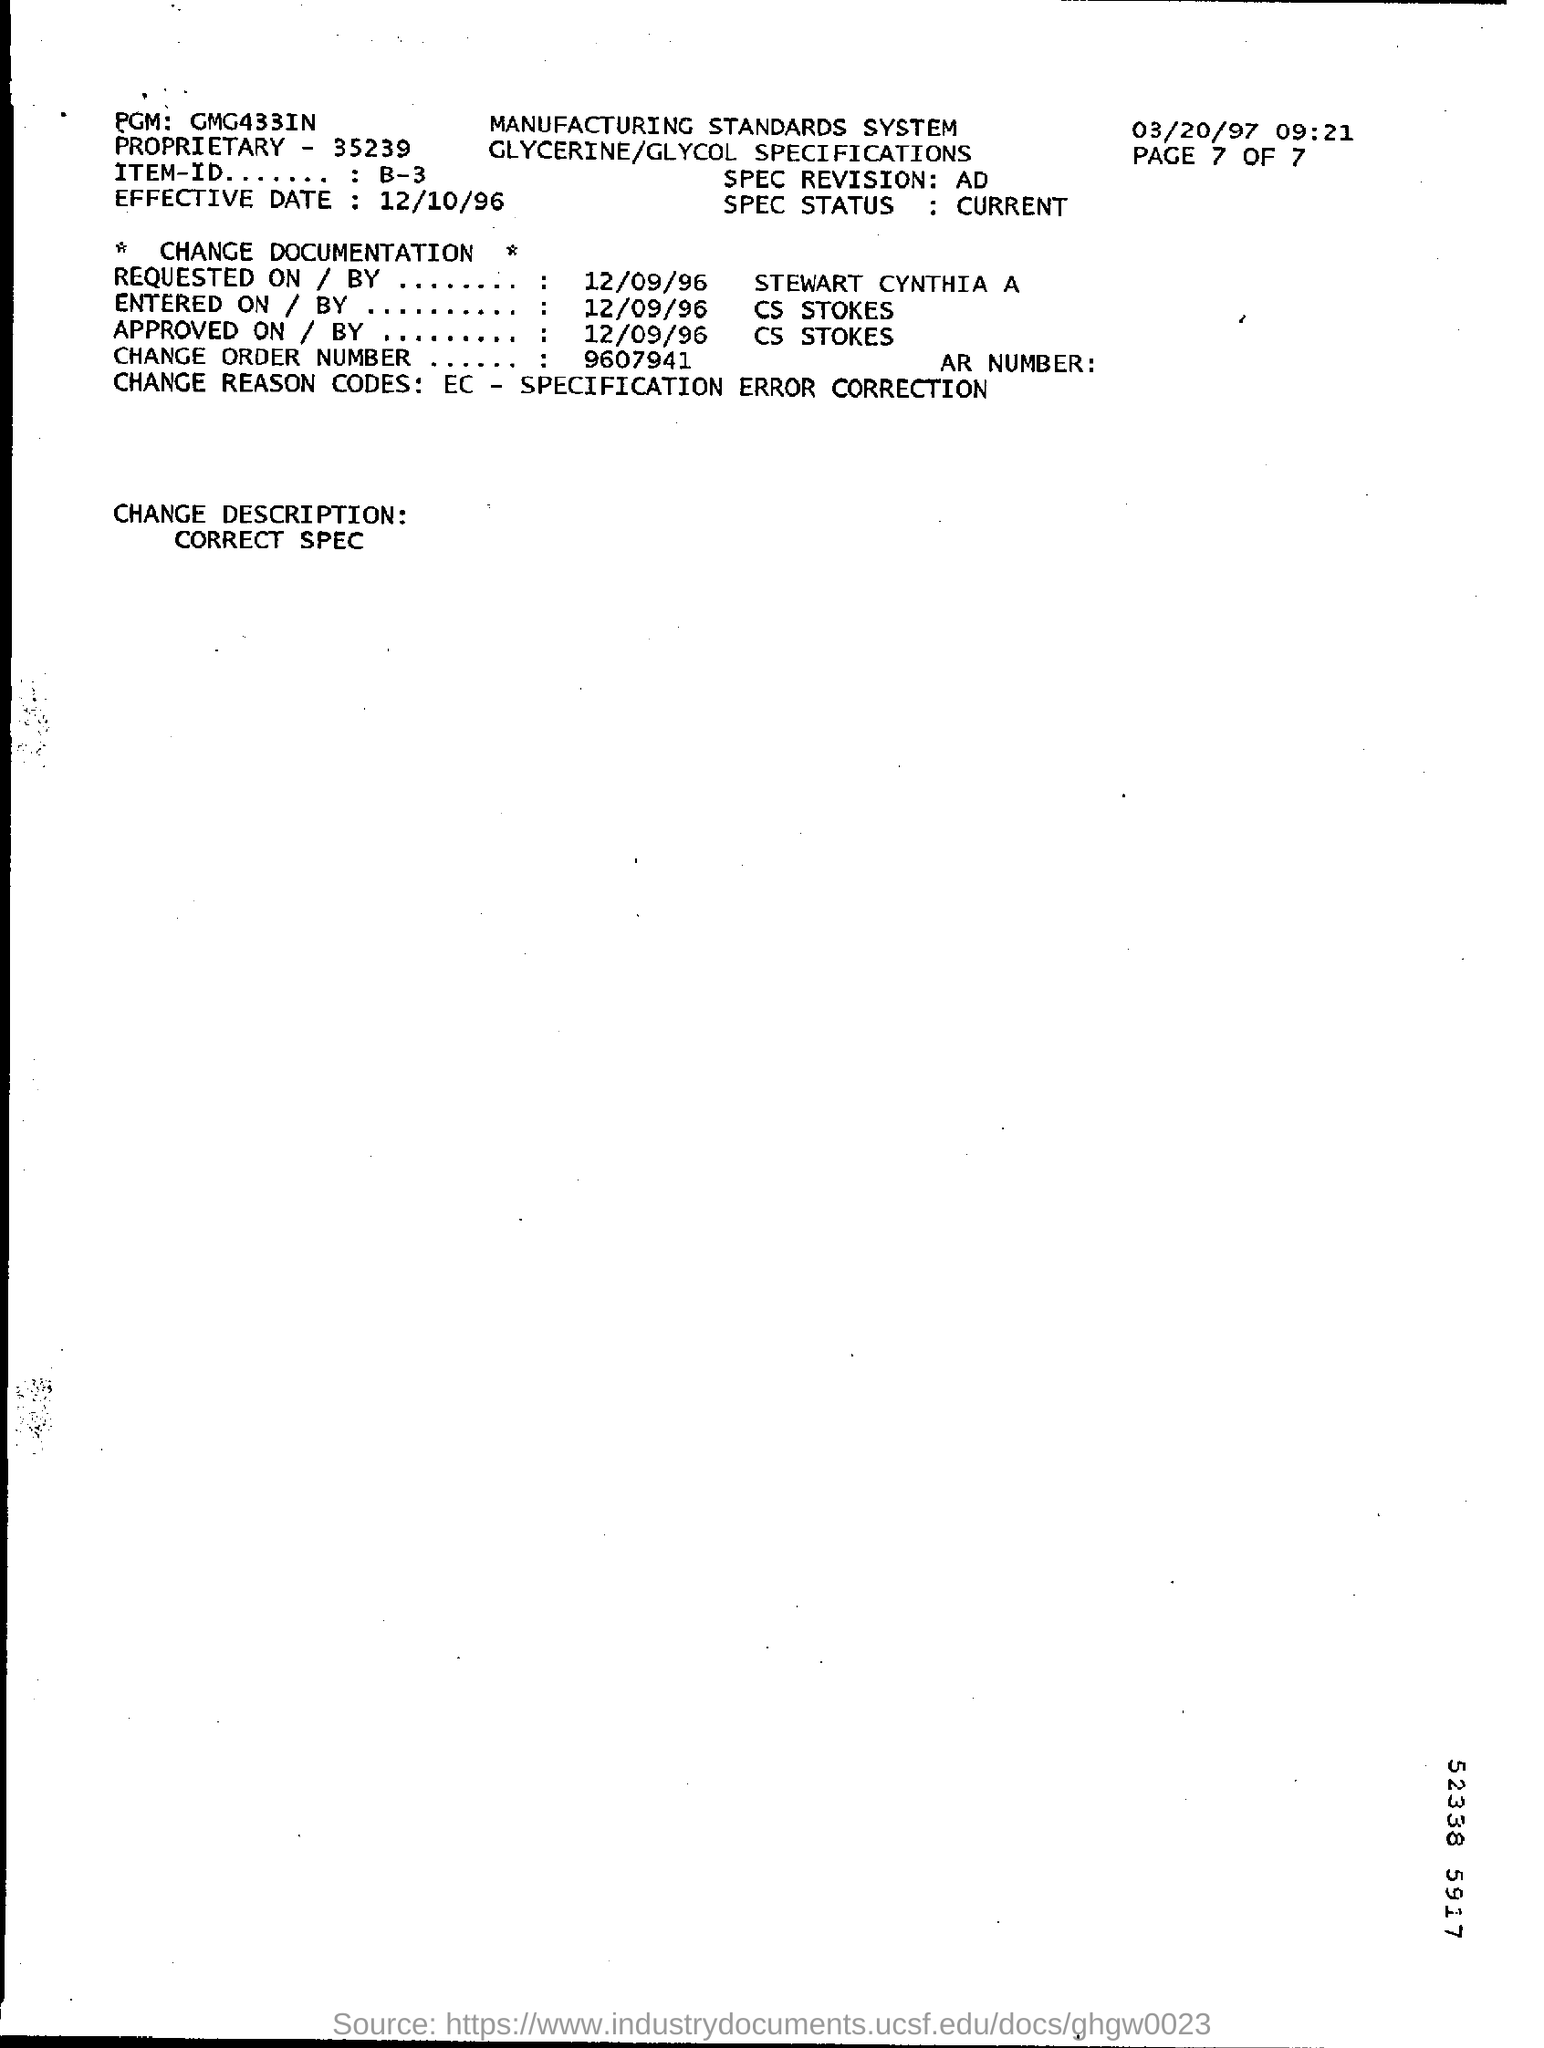When was the CHANGE DOCUMENTATION requested on?
Provide a succinct answer. 12/09/96. By whom was the CHANGE DOCUMENTATION approved?
Make the answer very short. CS STOKES. What is the SPEC STATUS?
Offer a terse response. CURRENT. 